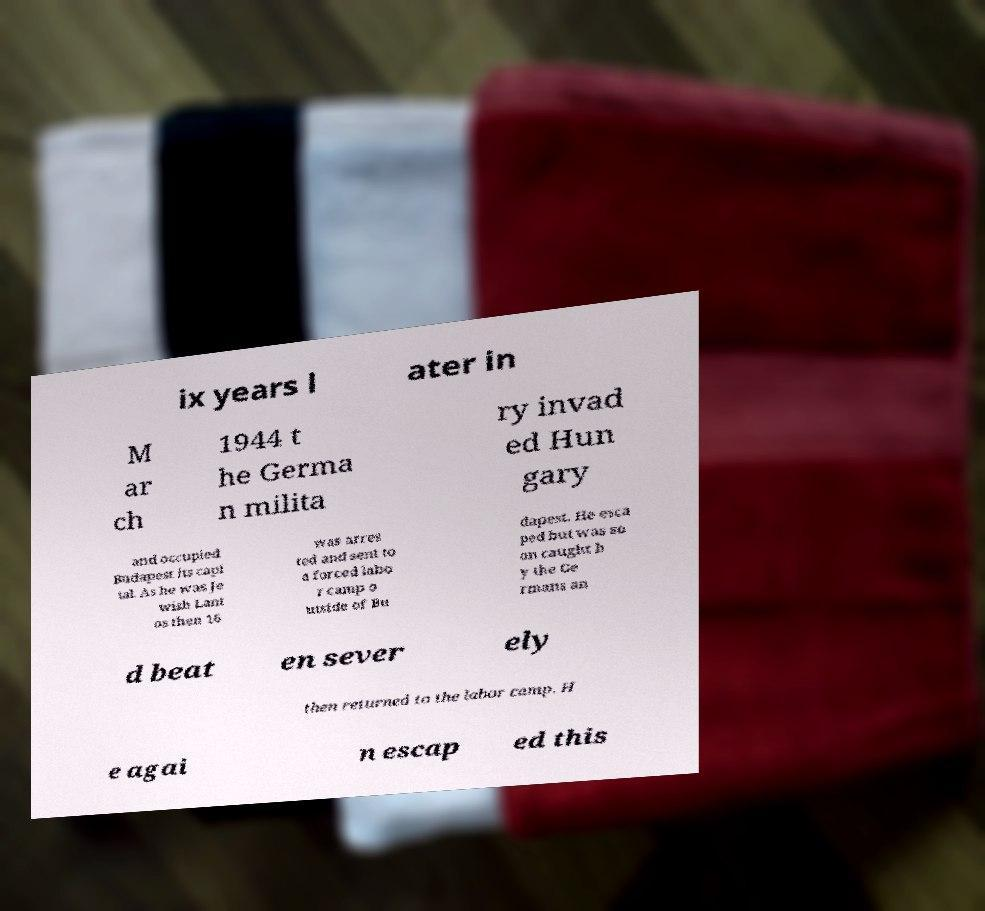What messages or text are displayed in this image? I need them in a readable, typed format. ix years l ater in M ar ch 1944 t he Germa n milita ry invad ed Hun gary and occupied Budapest its capi tal. As he was Je wish Lant os then 16 was arres ted and sent to a forced labo r camp o utside of Bu dapest. He esca ped but was so on caught b y the Ge rmans an d beat en sever ely then returned to the labor camp. H e agai n escap ed this 